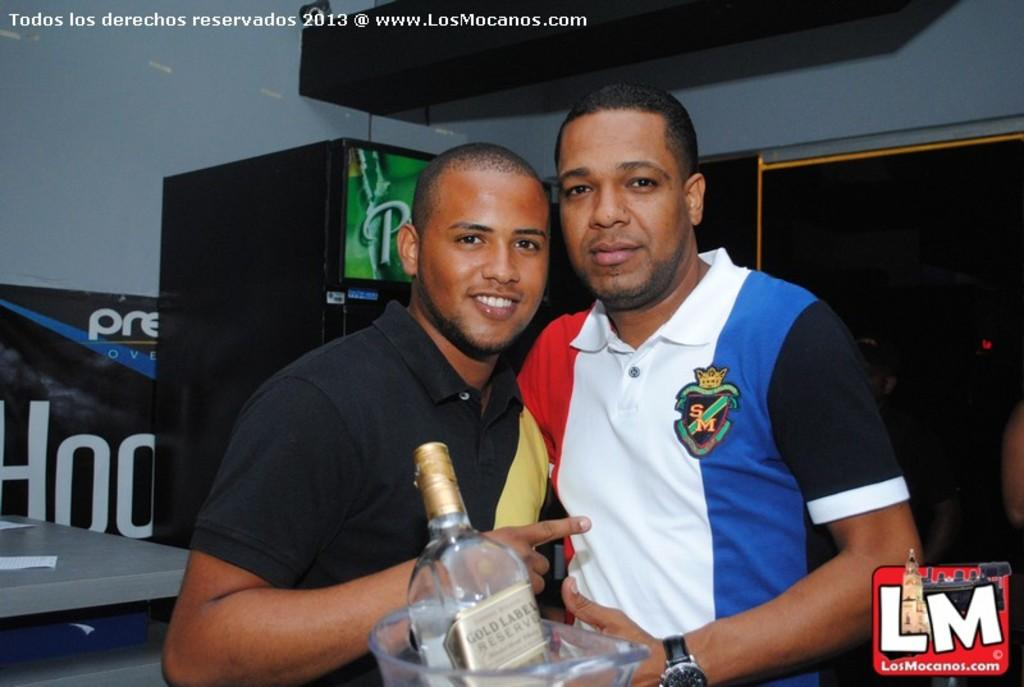How many people are in the image? There are two men in the image. What are the men doing in the image? The two men are standing together. What object are the men holding in the image? The men are holding a jar. What is inside the jar that the men are holding? There is a bottle in the jar. How deep is the quicksand in the image? There is no quicksand present in the image. What type of books are the men reading in the image? There are no books present in the image; the men are holding a jar with a bottle inside. 